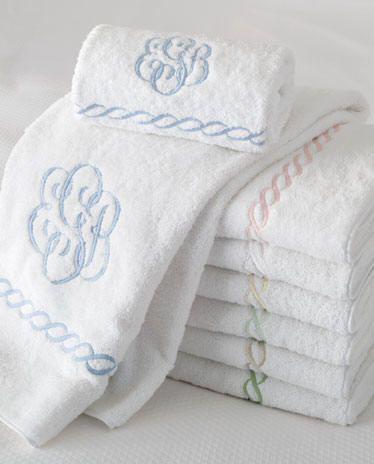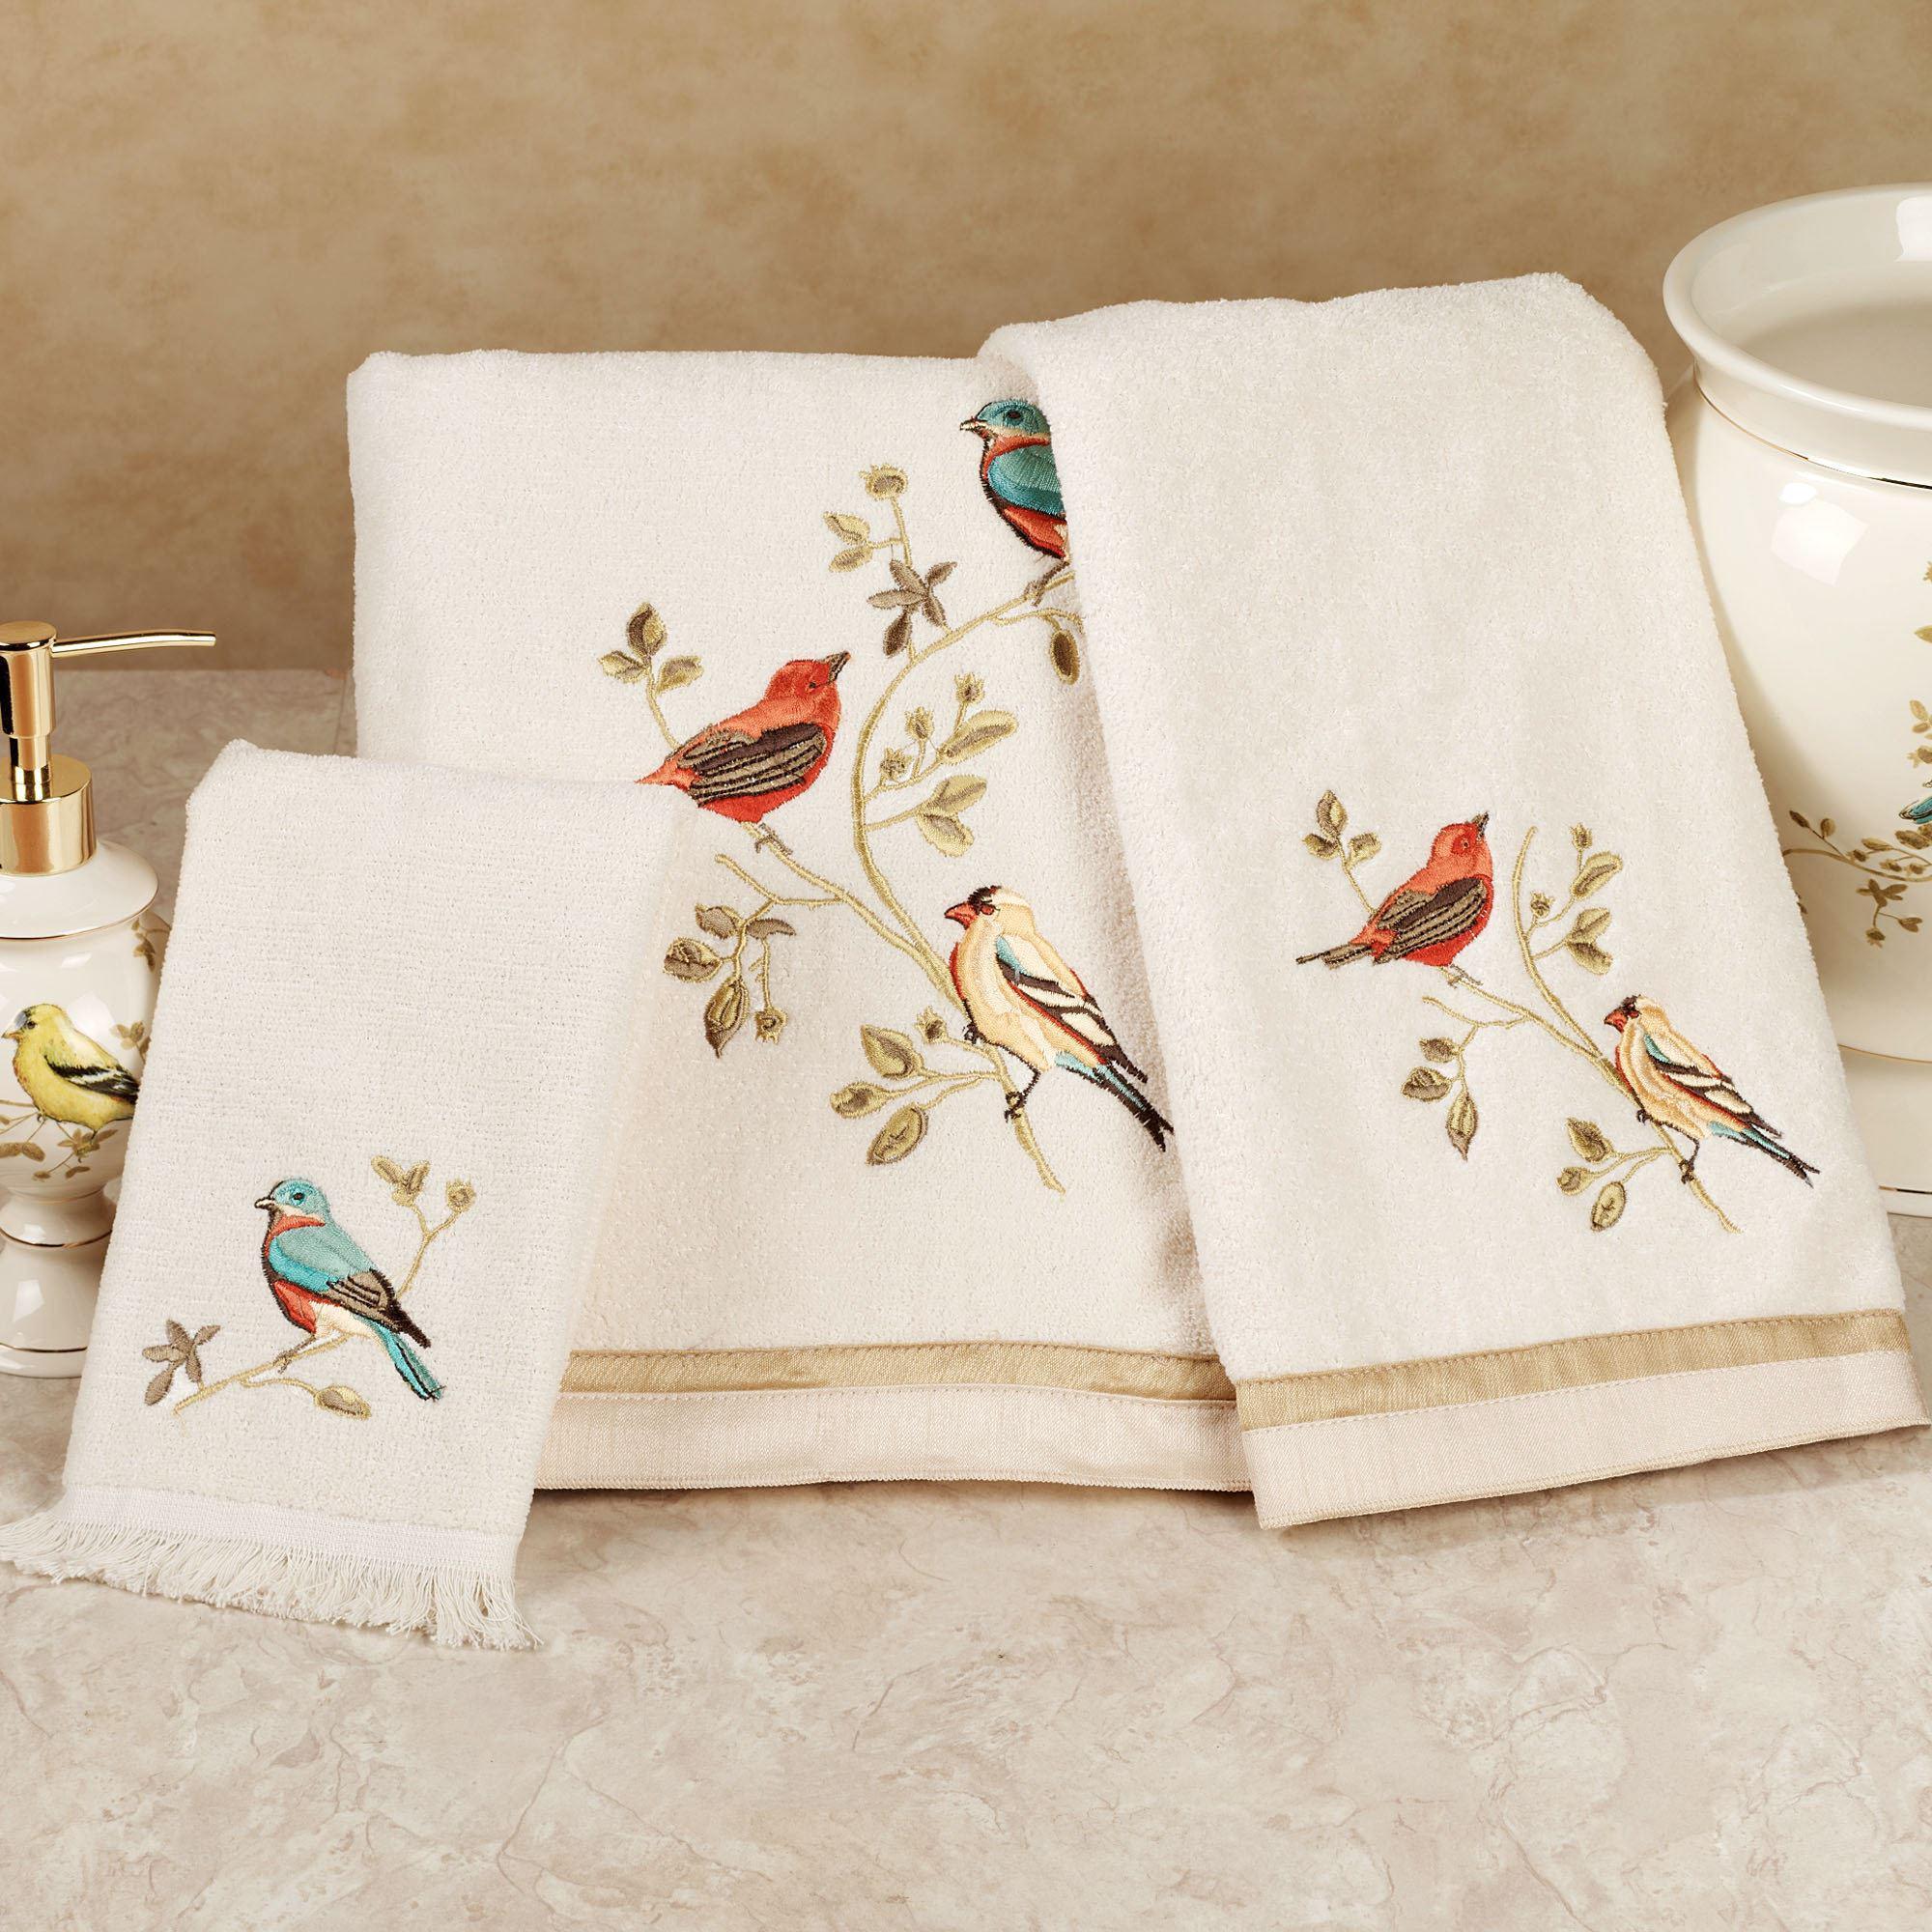The first image is the image on the left, the second image is the image on the right. Considering the images on both sides, is "There are three towels with birds on them in one of the images." valid? Answer yes or no. Yes. The first image is the image on the left, the second image is the image on the right. Analyze the images presented: Is the assertion "Hand towels with birds on them are resting on a counter" valid? Answer yes or no. Yes. 